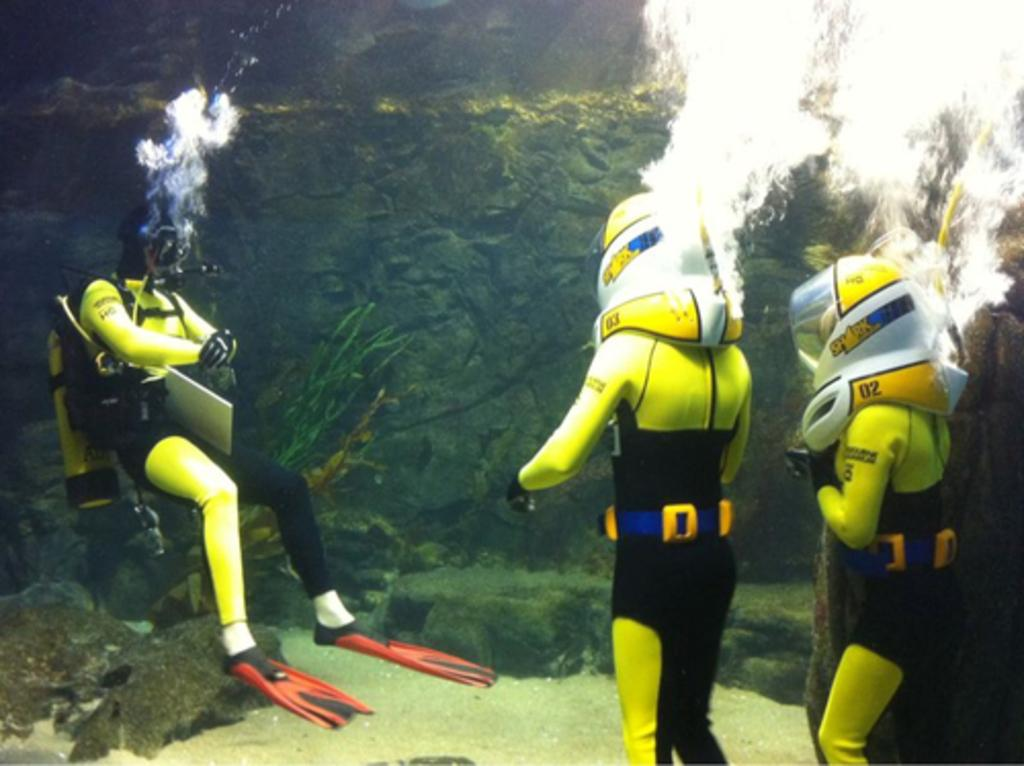What activity are the people in the image engaged in? The people in the image are doing scuba diving. Where are the people doing scuba diving? The people are in the water. What can be seen at the bottom of the image? There are water plants at the bottom of the image. What type of food is being served to the people in the image? There is no food present in the image; the people are doing scuba diving in the water. Can you see any boots in the image? There are no boots visible in the image; the people are wearing scuba diving gear. 